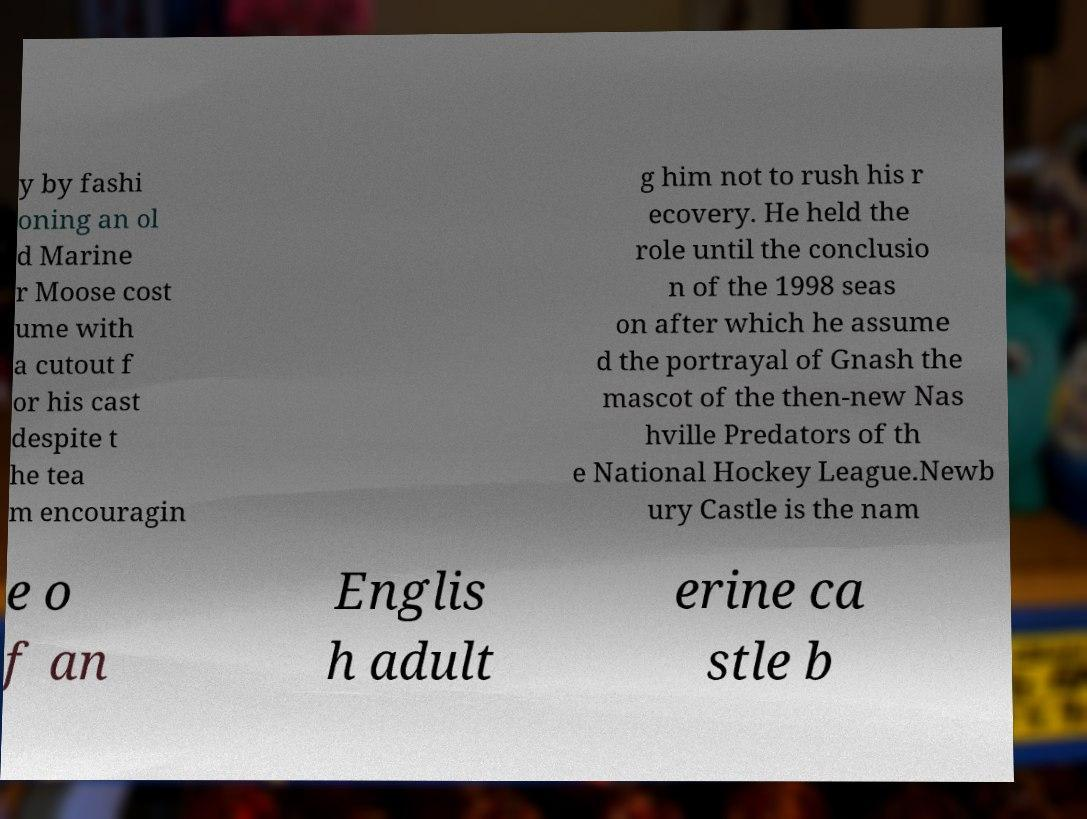Can you accurately transcribe the text from the provided image for me? y by fashi oning an ol d Marine r Moose cost ume with a cutout f or his cast despite t he tea m encouragin g him not to rush his r ecovery. He held the role until the conclusio n of the 1998 seas on after which he assume d the portrayal of Gnash the mascot of the then-new Nas hville Predators of th e National Hockey League.Newb ury Castle is the nam e o f an Englis h adult erine ca stle b 